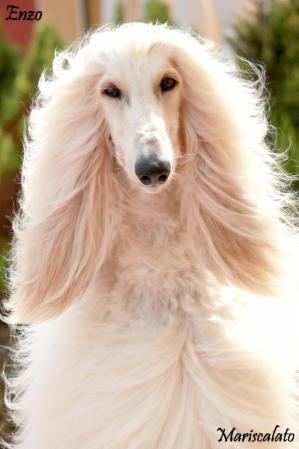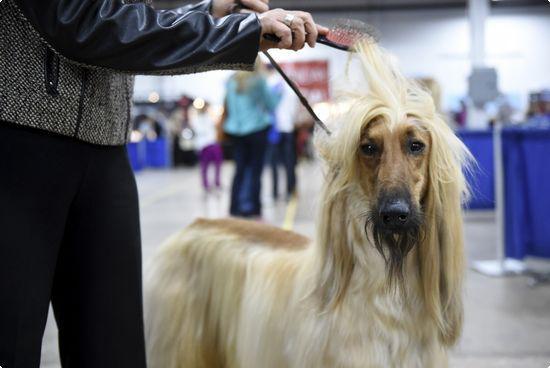The first image is the image on the left, the second image is the image on the right. Considering the images on both sides, is "There is an Afghan dog being held on a leash." valid? Answer yes or no. Yes. The first image is the image on the left, the second image is the image on the right. For the images displayed, is the sentence "One image shows a light-colored afghan hound gazing rightward into the distance." factually correct? Answer yes or no. No. 